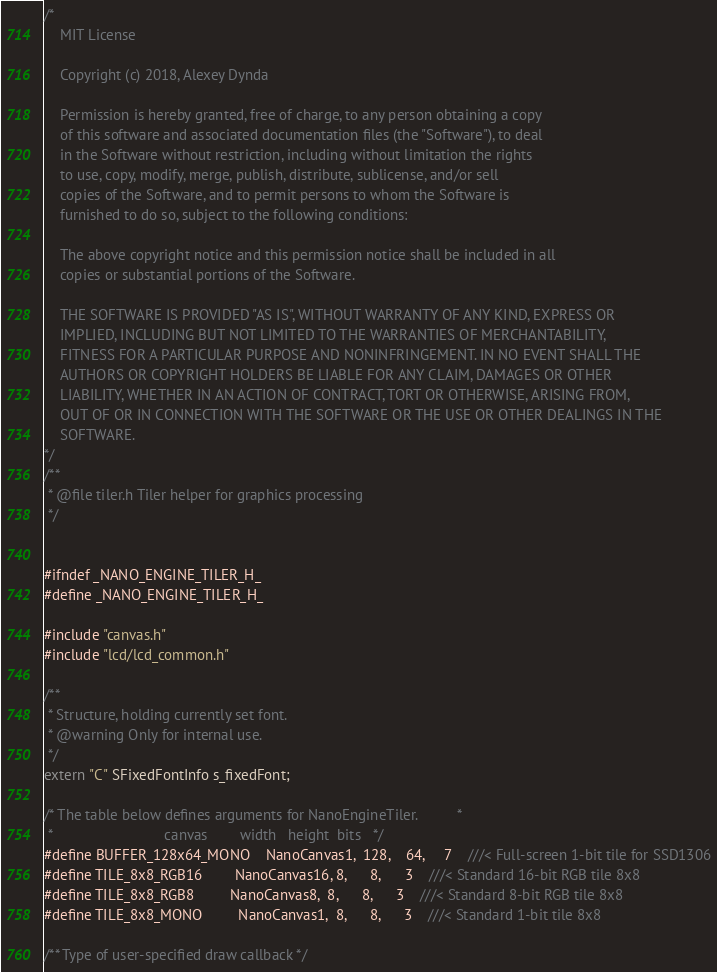<code> <loc_0><loc_0><loc_500><loc_500><_C_>/*
    MIT License

    Copyright (c) 2018, Alexey Dynda

    Permission is hereby granted, free of charge, to any person obtaining a copy
    of this software and associated documentation files (the "Software"), to deal
    in the Software without restriction, including without limitation the rights
    to use, copy, modify, merge, publish, distribute, sublicense, and/or sell
    copies of the Software, and to permit persons to whom the Software is
    furnished to do so, subject to the following conditions:

    The above copyright notice and this permission notice shall be included in all
    copies or substantial portions of the Software.

    THE SOFTWARE IS PROVIDED "AS IS", WITHOUT WARRANTY OF ANY KIND, EXPRESS OR
    IMPLIED, INCLUDING BUT NOT LIMITED TO THE WARRANTIES OF MERCHANTABILITY,
    FITNESS FOR A PARTICULAR PURPOSE AND NONINFRINGEMENT. IN NO EVENT SHALL THE
    AUTHORS OR COPYRIGHT HOLDERS BE LIABLE FOR ANY CLAIM, DAMAGES OR OTHER
    LIABILITY, WHETHER IN AN ACTION OF CONTRACT, TORT OR OTHERWISE, ARISING FROM,
    OUT OF OR IN CONNECTION WITH THE SOFTWARE OR THE USE OR OTHER DEALINGS IN THE
    SOFTWARE.
*/
/**
 * @file tiler.h Tiler helper for graphics processing
 */


#ifndef _NANO_ENGINE_TILER_H_
#define _NANO_ENGINE_TILER_H_

#include "canvas.h"
#include "lcd/lcd_common.h"

/**
 * Structure, holding currently set font.
 * @warning Only for internal use.
 */
extern "C" SFixedFontInfo s_fixedFont;

/* The table below defines arguments for NanoEngineTiler.          *
 *                            canvas        width   height  bits   */
#define BUFFER_128x64_MONO    NanoCanvas1,  128,    64,     7    ///< Full-screen 1-bit tile for SSD1306
#define TILE_8x8_RGB16        NanoCanvas16, 8,      8,      3    ///< Standard 16-bit RGB tile 8x8
#define TILE_8x8_RGB8         NanoCanvas8,  8,      8,      3    ///< Standard 8-bit RGB tile 8x8
#define TILE_8x8_MONO         NanoCanvas1,  8,      8,      3    ///< Standard 1-bit tile 8x8

/** Type of user-specified draw callback */</code> 